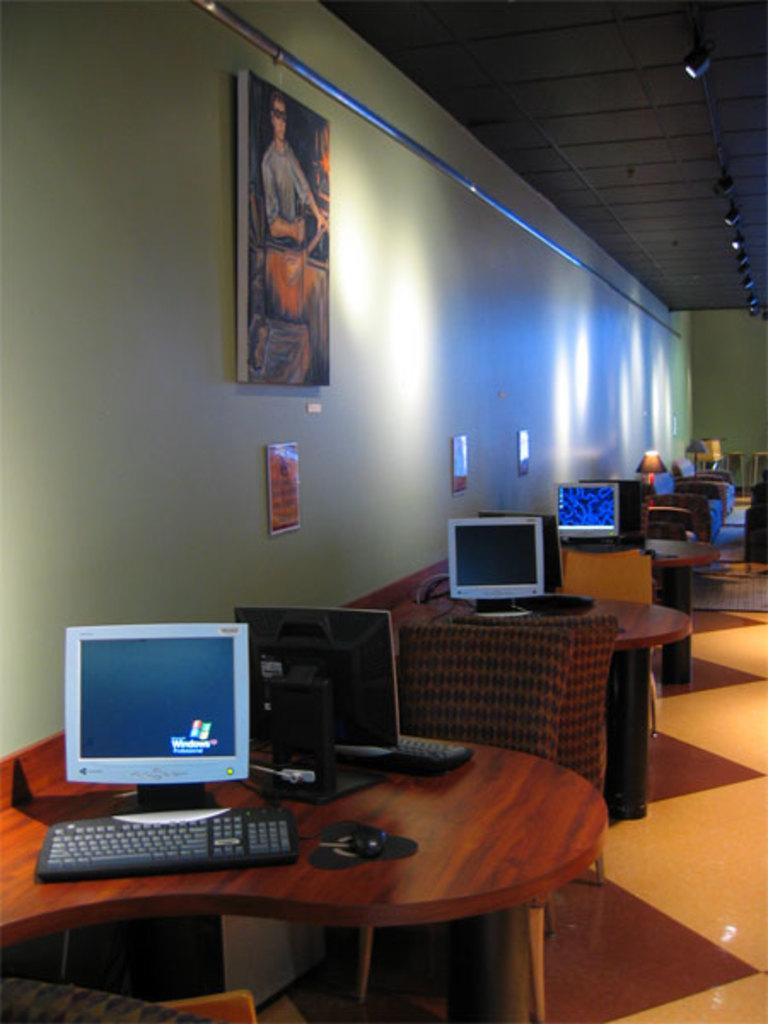What type of furniture is present in the image? There is a wooden table and a chair in the image. What electronic device can be seen in the image? There is a computer in the image. What is used for typing on the computer in the image? There is a keyboard in the image. What is hanging on the wall in the image? There is a photo frame on the wall in the image. What type of lighting is present in the image? There is a table lamp in the image. What type of kettle is visible on the table in the image? There is no kettle present in the image; only a computer, keyboard, table lamp, and photo frame are visible on the table. 